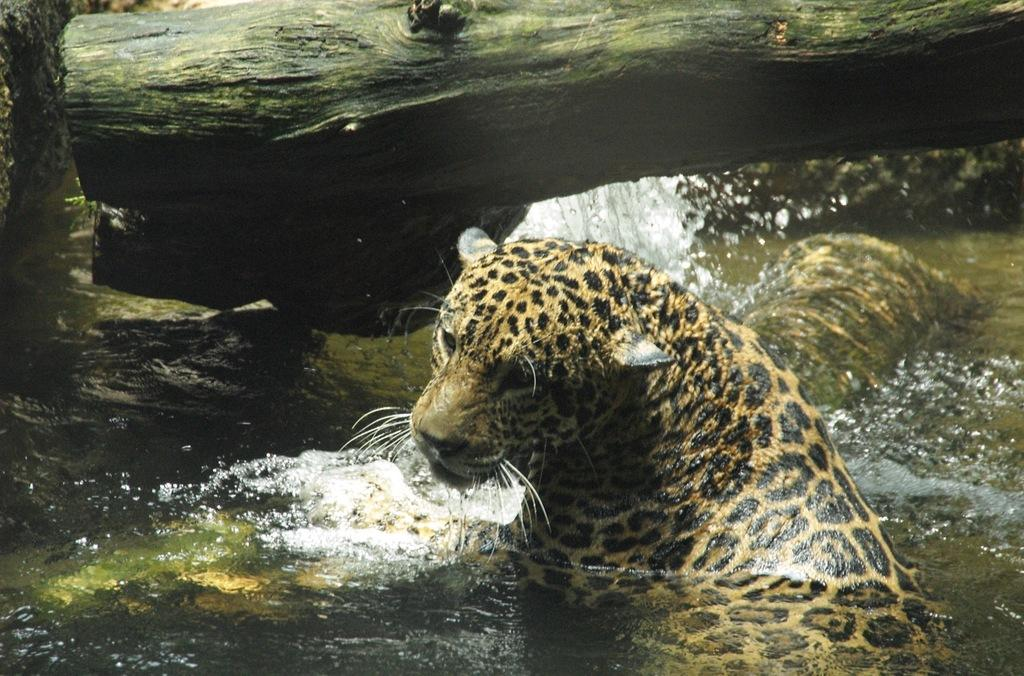What is the main element present in the image? There is water in the image. What animal can be seen in the water? There is a cheetah in the water. What type of surface is near the cheetah? There is a rock surface near the cheetah. What object can be seen behind the cheetah? There is a tree log visible behind the cheetah. How many pairs of shoes can be seen in the image? There are no shoes present in the image. What type of bird is perched on the tree log in the image? There is no bird, specifically an owl, present in the image. 